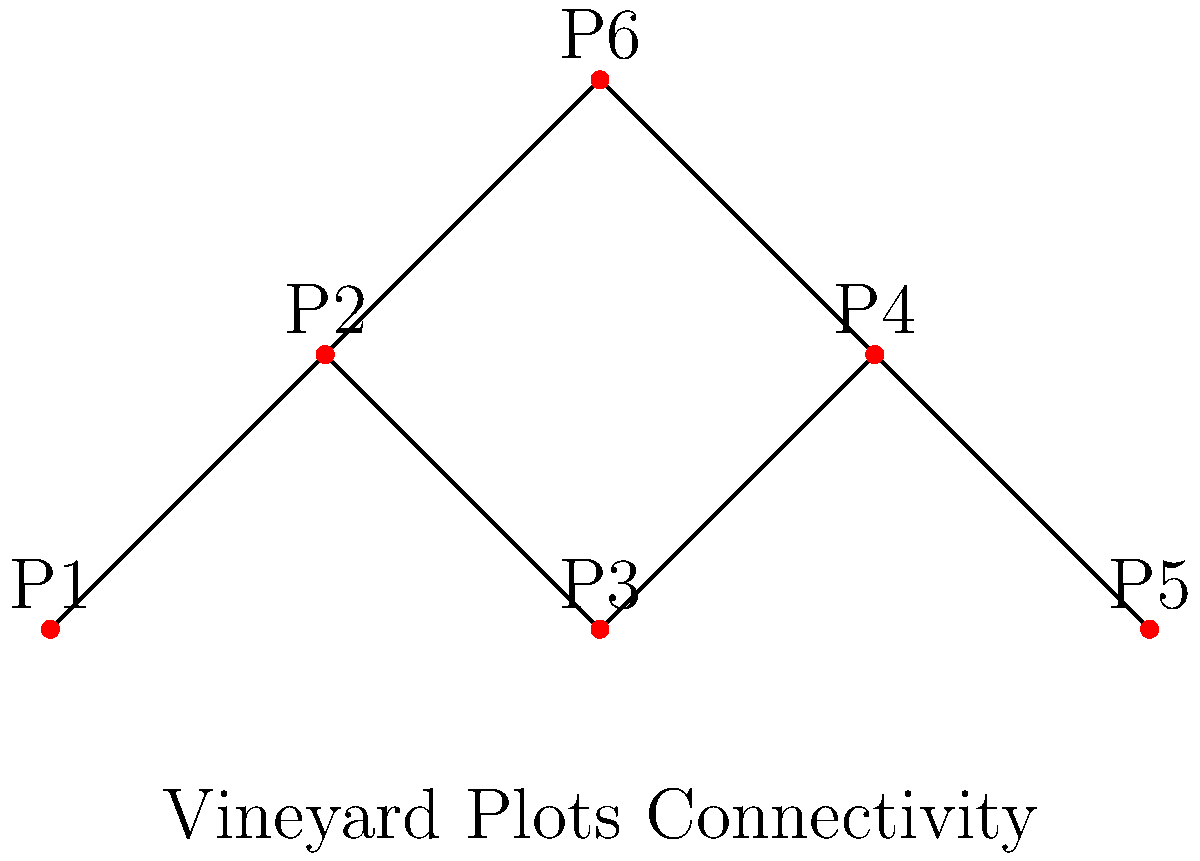In the land ownership graph of vineyard plots, where each node represents a plot and edges represent adjacent plots, what is the minimum number of plots that need to be acquired to ensure a continuous path from Plot 1 (P1) to Plot 5 (P5)? To solve this problem, we need to analyze the connectivity of the graph and find the minimum number of plots required to create a continuous path from P1 to P5. Let's break it down step-by-step:

1. Observe the graph structure:
   - The graph shows 6 plots (P1 to P6) represented as nodes.
   - Edges between nodes represent adjacent plots.

2. Identify possible paths from P1 to P5:
   - Path 1: P1 - P2 - P3 - P4 - P5
   - Path 2: P1 - P2 - P6 - P4 - P5

3. Analyze the minimum number of plots needed:
   - Both paths require 5 plots (including P1 and P5).
   - We need to count P1 and P5 as they are the start and end points.

4. Consider if any plots can be skipped:
   - No plots can be skipped in either path without breaking continuity.

5. Determine the minimum number:
   - Since both paths require 5 plots and no plots can be skipped, the minimum number of plots needed is 5.

Therefore, to ensure a continuous path from Plot 1 (P1) to Plot 5 (P5), a minimum of 5 plots need to be acquired.
Answer: 5 plots 